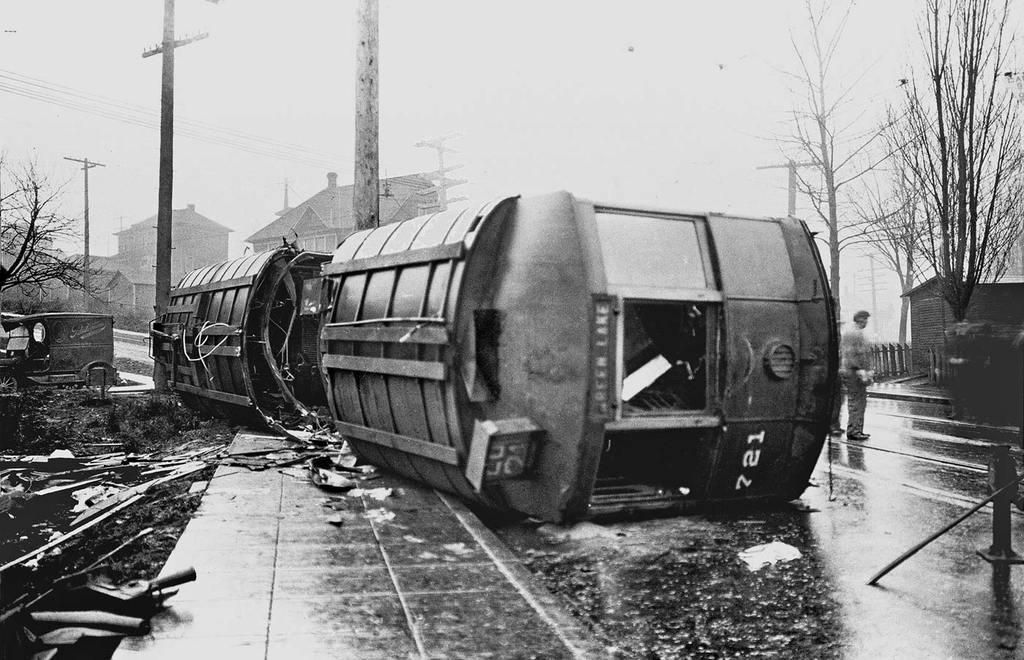Can you describe this image briefly? This is a black and white picture. In this picture we can see a person standing on the road, grass, trees, buildings, poles, some objects and in the background we can see the sky. 